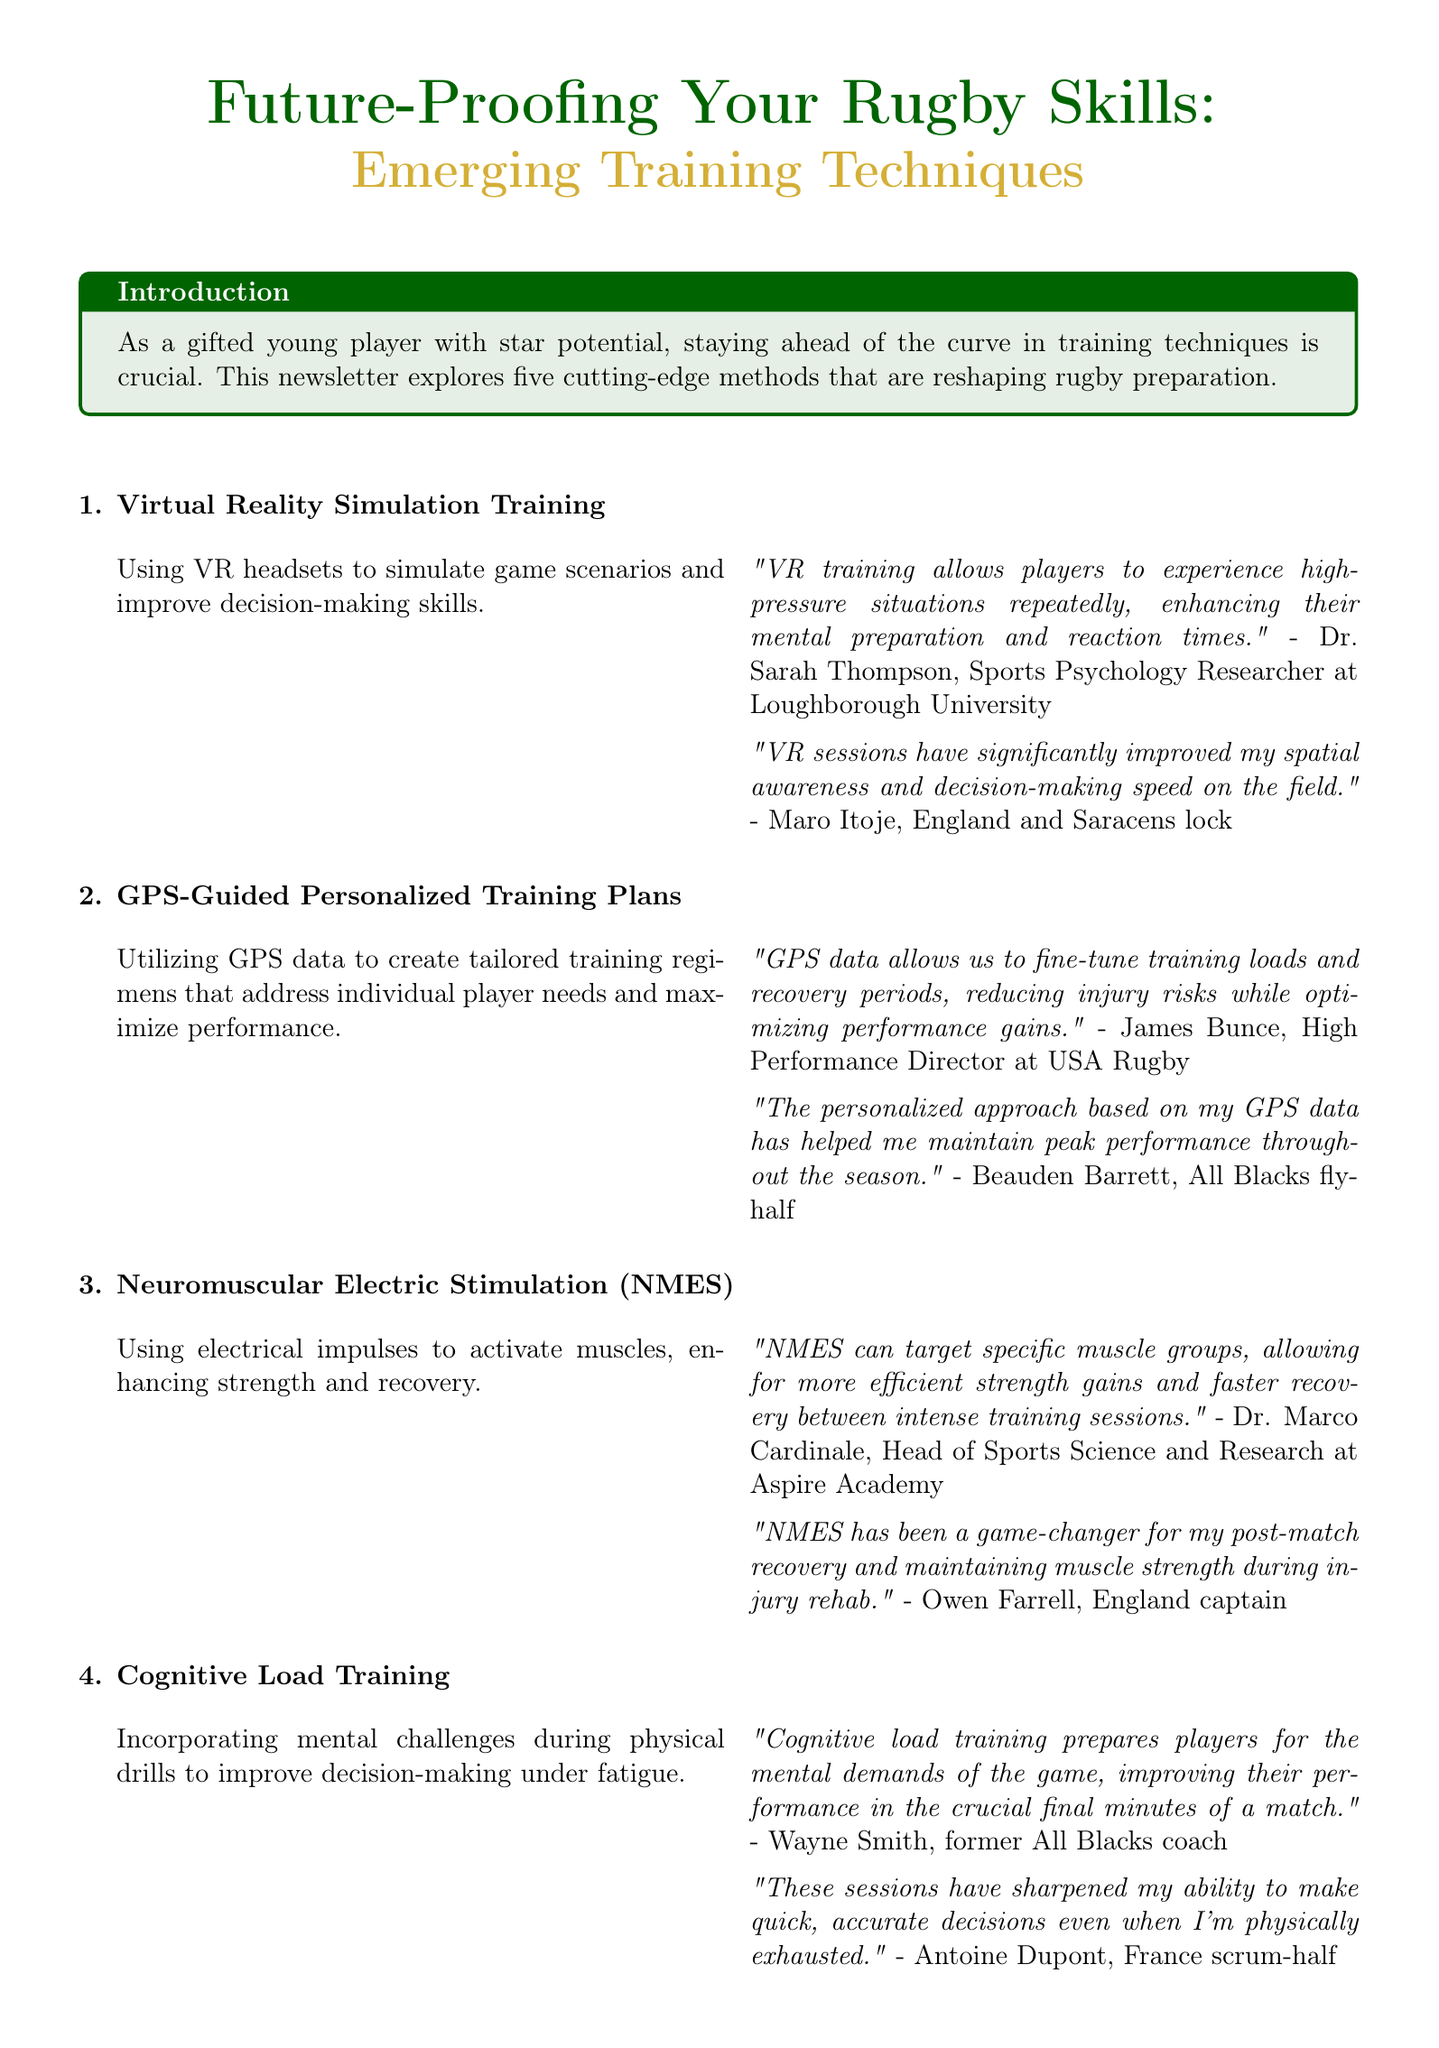What is the title of the newsletter? The title is found at the beginning of the document, outlining the main theme of the newsletter.
Answer: Future-Proofing Your Rugby Skills: Emerging Training Techniques Who is the expert behind Virtual Reality Simulation Training? The document provides insights from various experts, including their names and roles related to each training technique.
Answer: Dr. Sarah Thompson What does NMES stand for? The acronym is referenced in the document, specifically in the description section about a training method.
Answer: Neuromuscular Electric Stimulation Which rugby player mentioned the benefits of altitude mask training? The document includes testimonials from various players sharing their personal experiences with emerging training techniques.
Answer: Cheslin Kolbe How many emerging training techniques are discussed in the newsletter? The total number of techniques is explicitly stated in the document's introduction and main sections.
Answer: Five What is one main benefit of GPS-Guided Personalized Training Plans? The expert insight related to this technique highlights a specific advantage derived from using GPS data.
Answer: Reducing injury risks Which technique improves decision-making under fatigue? This is directly mentioned in the description of a specific training method within the newsletter.
Answer: Cognitive Load Training What does Ben Ryan refer to regarding altitude mask training? The document contains expert insights that discuss the impact of altitude mask training on performance.
Answer: Boost a player's VO2 max Who is the target audience of the newsletter? The introduction clearly defines the primary audience for the content being shared in the newsletter.
Answer: Gifted young players 